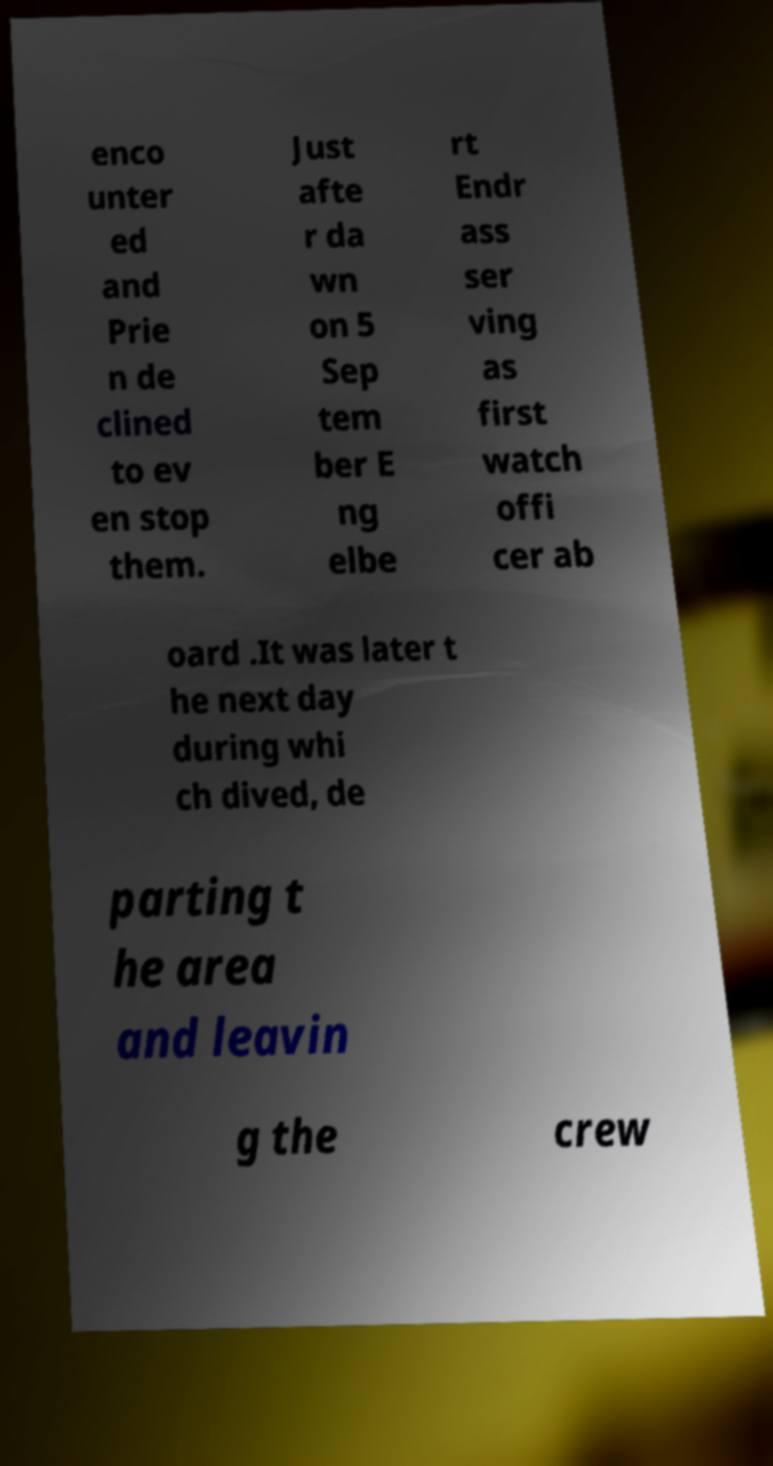For documentation purposes, I need the text within this image transcribed. Could you provide that? enco unter ed and Prie n de clined to ev en stop them. Just afte r da wn on 5 Sep tem ber E ng elbe rt Endr ass ser ving as first watch offi cer ab oard .It was later t he next day during whi ch dived, de parting t he area and leavin g the crew 